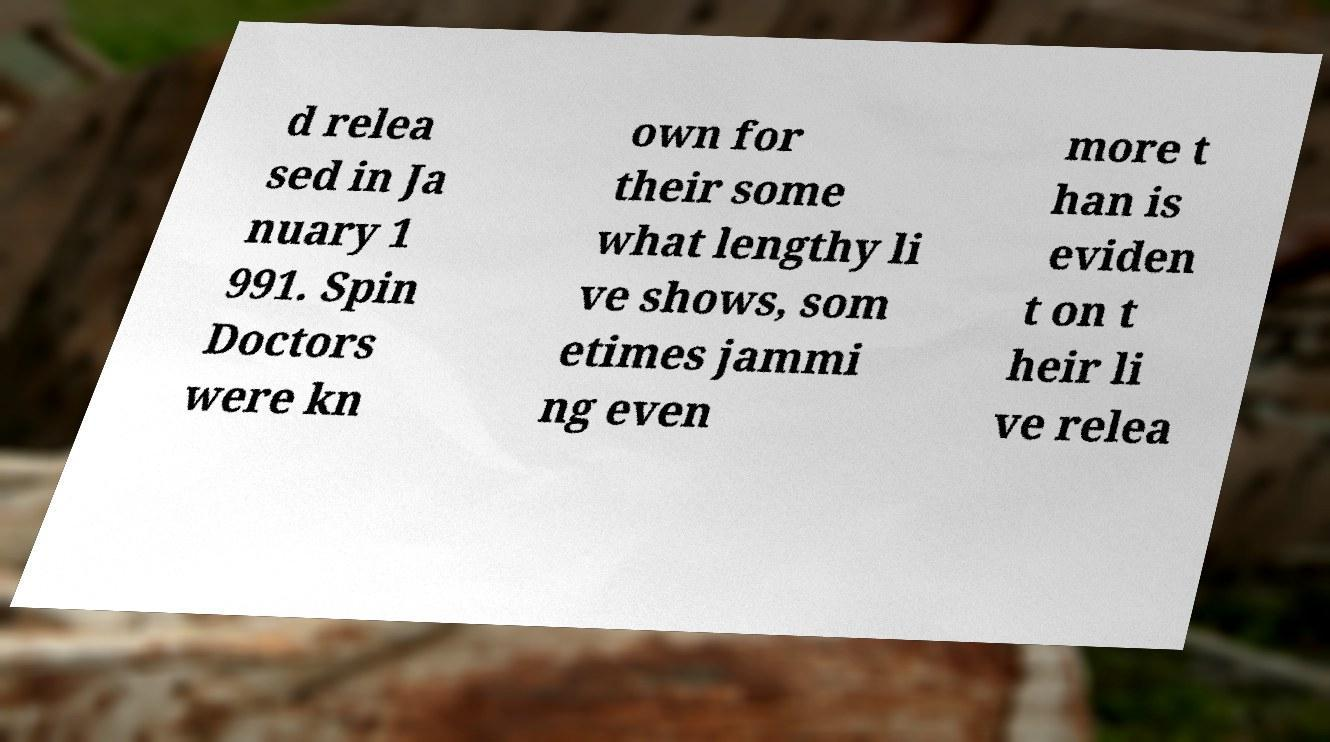Can you read and provide the text displayed in the image?This photo seems to have some interesting text. Can you extract and type it out for me? d relea sed in Ja nuary 1 991. Spin Doctors were kn own for their some what lengthy li ve shows, som etimes jammi ng even more t han is eviden t on t heir li ve relea 